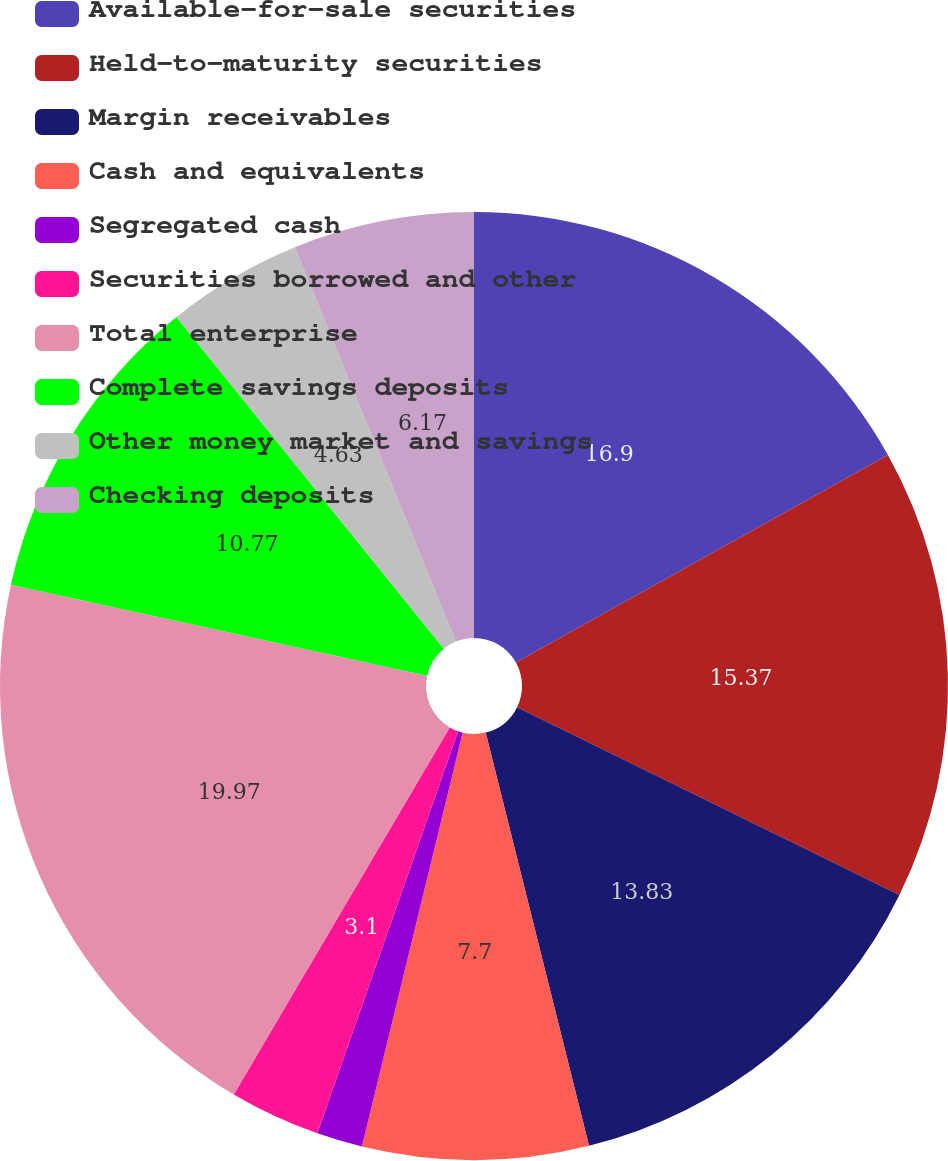<chart> <loc_0><loc_0><loc_500><loc_500><pie_chart><fcel>Available-for-sale securities<fcel>Held-to-maturity securities<fcel>Margin receivables<fcel>Cash and equivalents<fcel>Segregated cash<fcel>Securities borrowed and other<fcel>Total enterprise<fcel>Complete savings deposits<fcel>Other money market and savings<fcel>Checking deposits<nl><fcel>16.9%<fcel>15.37%<fcel>13.83%<fcel>7.7%<fcel>1.56%<fcel>3.1%<fcel>19.97%<fcel>10.77%<fcel>4.63%<fcel>6.17%<nl></chart> 